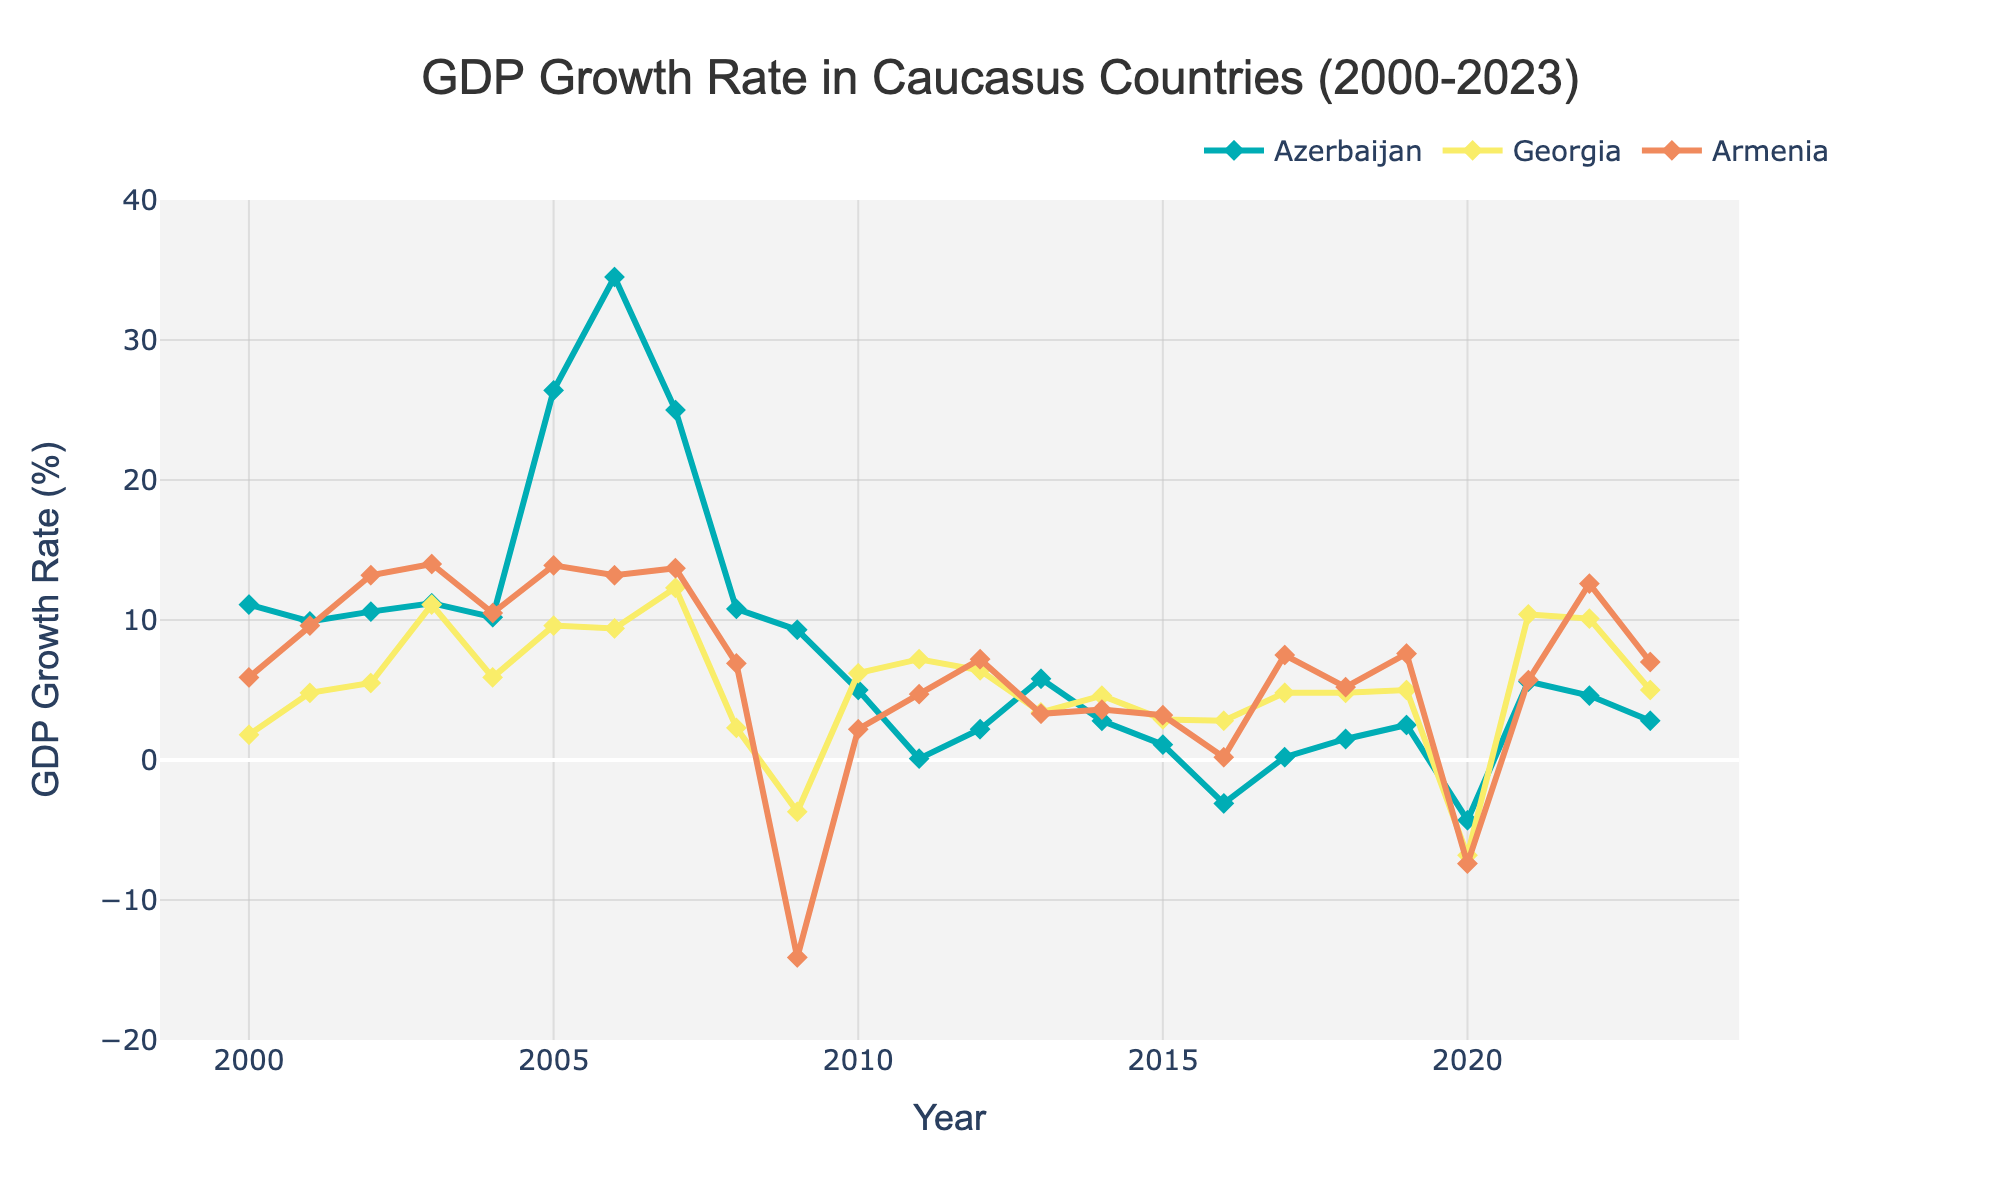What is the highest GDP growth rate observed for Azerbaijan between 2000 and 2023? Find the highest point on the line representing Azerbaijan's GDP growth rate on the chart. It's in the year 2006 at 34.5%.
Answer: 34.5% In which year did Georgia experience its lowest GDP growth rate between 2000 and 2023? Locate Georgia's lowest point on the graph. In 2009, Georgia's GDP growth rate was -3.7%.
Answer: 2009 How did Armenia's GDP growth rate in 2022 compare to its rate in 2020? Identify Armenia's GDP growth rate in 2022 and 2020 from the chart, then compare them. Armenia had a rate of 12.6% in 2022 and -7.4% in 2020. 12.6% - 7.4% = 20% increase.
Answer: 20% increase Which country had the least fluctuation in GDP growth rates between 2000 and 2023? Look at the GDP growth lines for Azerbaijan, Georgia, and Armenia. The least fluctuation seems to be in Georgia, which had a relatively more stable trend compared to the more volatile Azerbaijan and Armenia.
Answer: Georgia What was the average GDP growth rate for Azerbaijan during the years it experienced positive growth? Identify all years where Azerbaijan's growth was positive, sum up these rates, and then divide by the count of those years: (11.1 + 9.9 + 10.6 + 11.2 + 10.2 + 26.4 + 34.5 + 25.0 + 10.8 + 9.3 + 5.0 + 0.1 + 2.2 + 5.8 + 2.8 + 1.1 + 0.2 + 1.5 + 2.5 + 5.6 + 4.6 + 2.8) / 22 = 8.75%.
Answer: 8.75% In which year did all three countries experience a decline in GDP growth rate? Find the year where all three lines dip into negative growth. This occurs in 2020 where Azerbaijan (-4.3%), Georgia (-6.8%), and Armenia (-7.4%) experienced declines.
Answer: 2020 During which periods did Azerbaijan's GDP growth surpass both Georgia and Armenia simultaneously? Observe the graph to find where Azerbaijan's growth rate is above those of both Georgia and Armenia. This occurs from 2005 to 2008.
Answer: 2005-2008 What is the difference between the highest GDP growth rate of Armenia and Azerbaijan between 2000 and 2023? Find the highest rates for both Armenia (14.0% in 2003) and Azerbaijan (34.5% in 2006), then calculate the difference: 34.5% - 14.0% = 20.5%.
Answer: 20.5% Which year had the smallest difference in GDP growth rates between Azerbaijan and Georgia? Compare yearly differences of GDP growth rates between Azerbaijan and Georgia to find the smallest one. In 2013, the difference was 5.8% - 3.4% = 2.4%, which is the smallest.
Answer: 2013 What was the trend in GDP growth rates for Armenia from 2016 to 2023? Track Armenia's GDP growth line from 2016 to 2023: It starts at 0.2% in 2016, rises to 7.5% in 2017, fluctuates around 5-7% until 2020, drops in 2020 to -7.4%, then rises to 12.6% in 2022 before settling at 7.0% in 2023.
Answer: Fluctuating, with an overall increase after 2020 